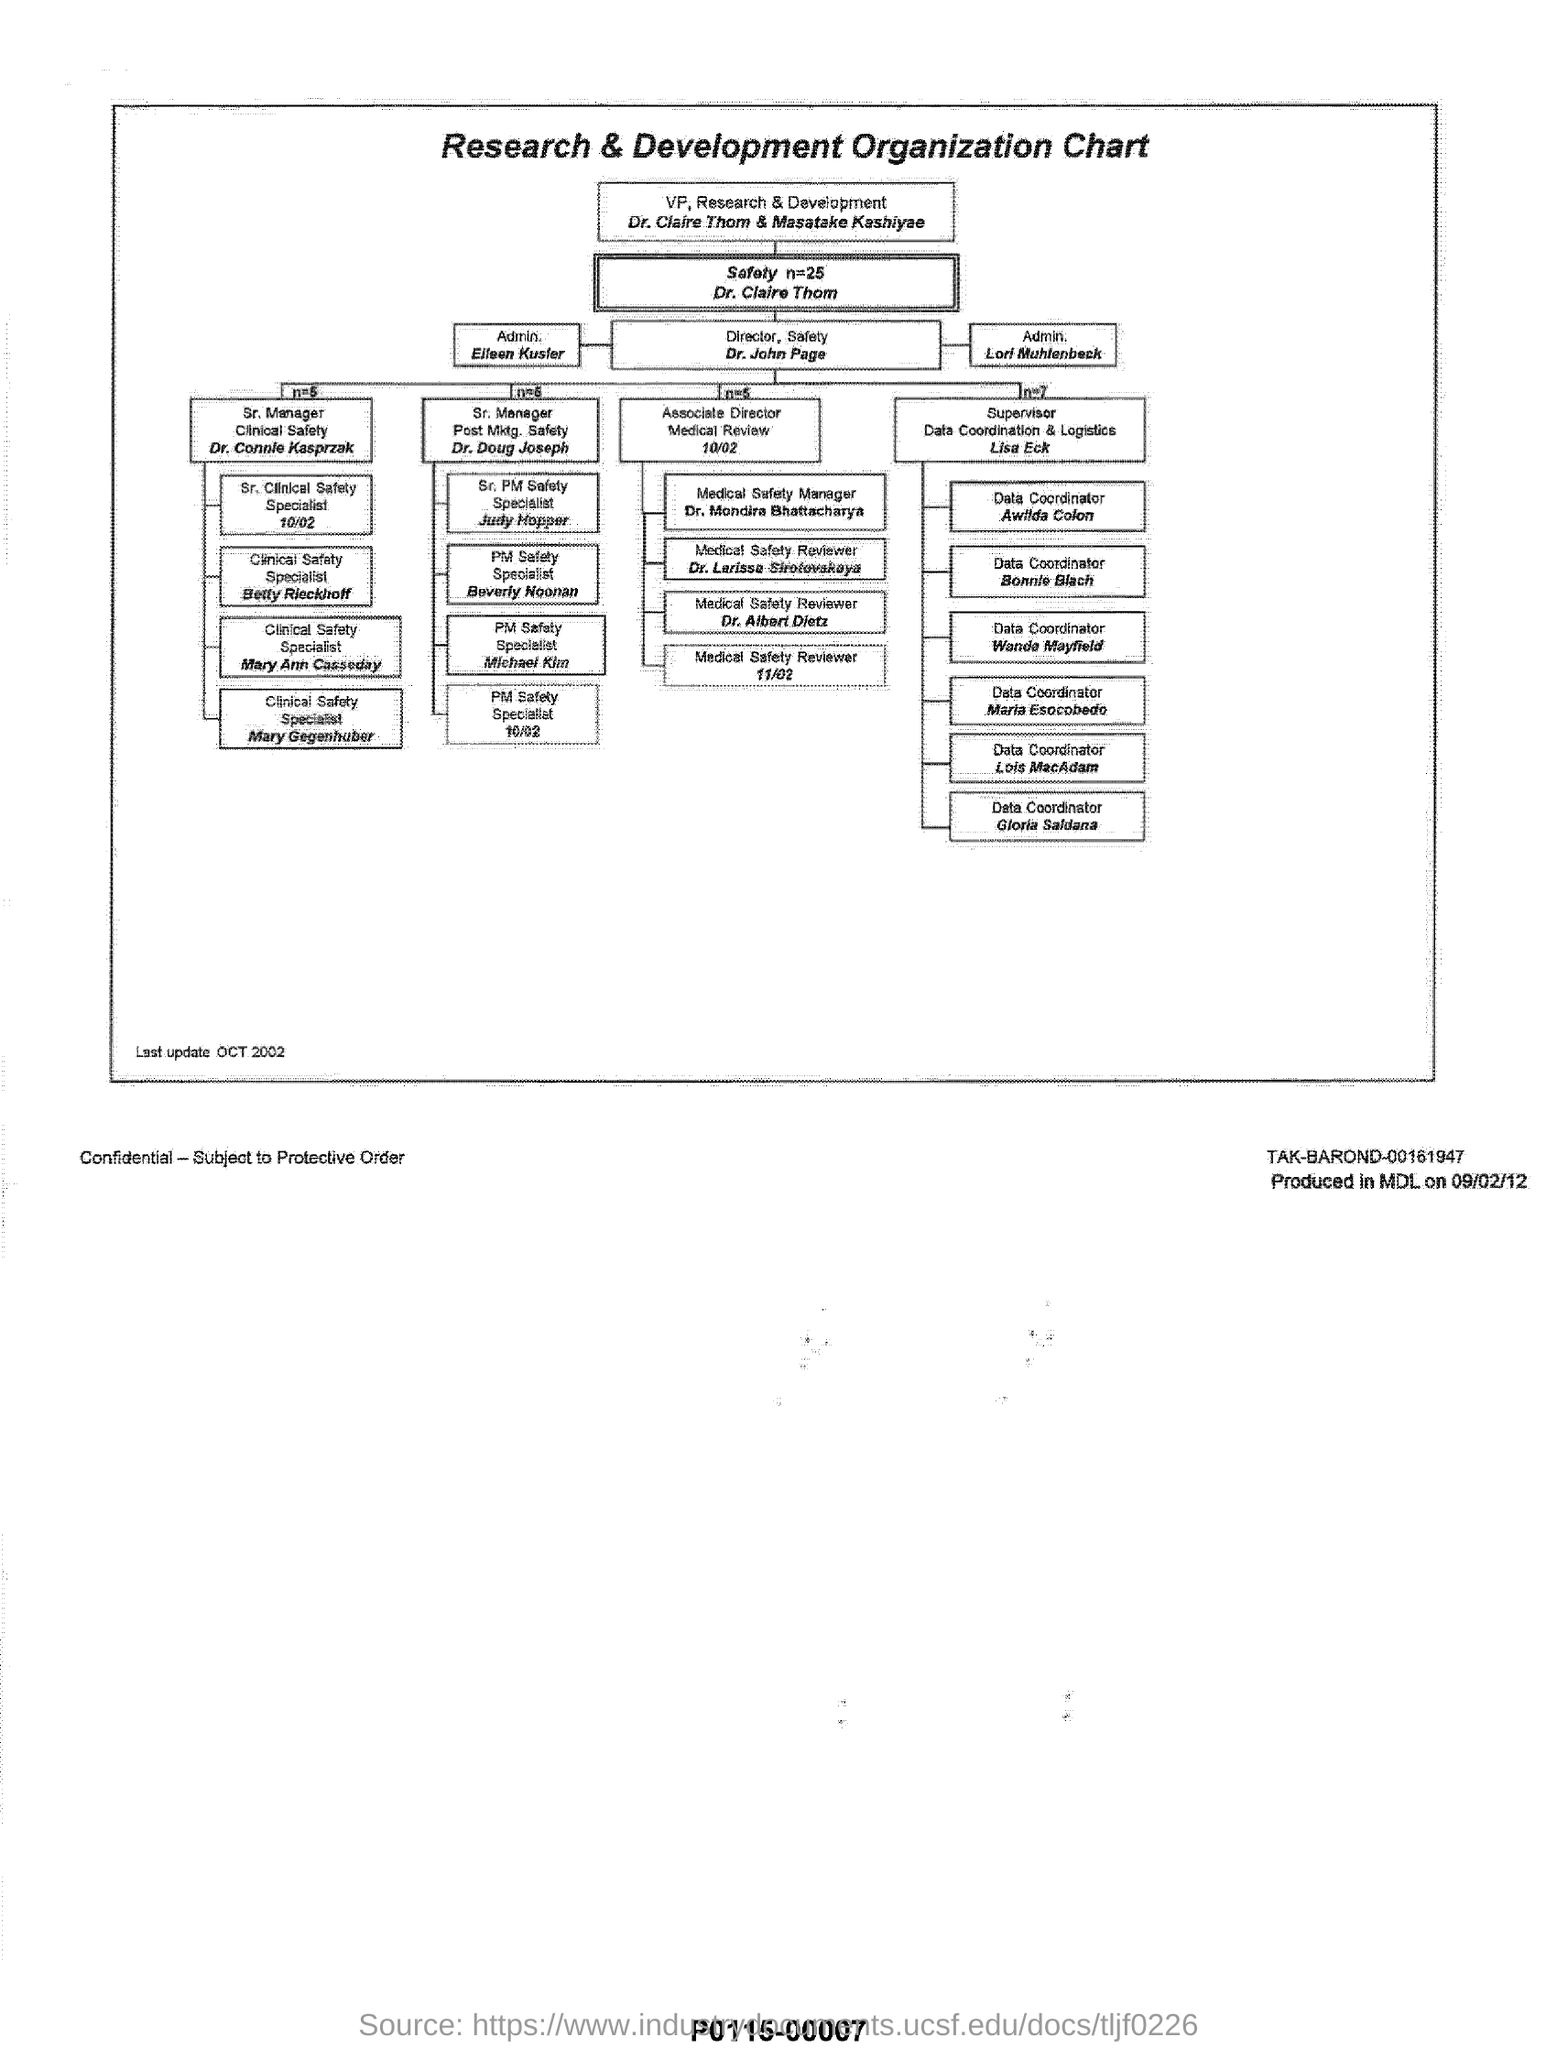Point out several critical features in this image. The Director of Safety is Dr. John Page. Dr. Claire Thom and Masatake Kashiyae are the VP of Research & Development. 